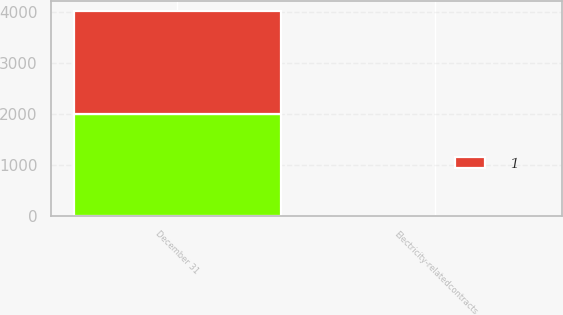Convert chart. <chart><loc_0><loc_0><loc_500><loc_500><stacked_bar_chart><ecel><fcel>December 31<fcel>Electricity-relatedcontracts<nl><fcel>nan<fcel>2007<fcel>4<nl><fcel>1<fcel>2006<fcel>2<nl></chart> 